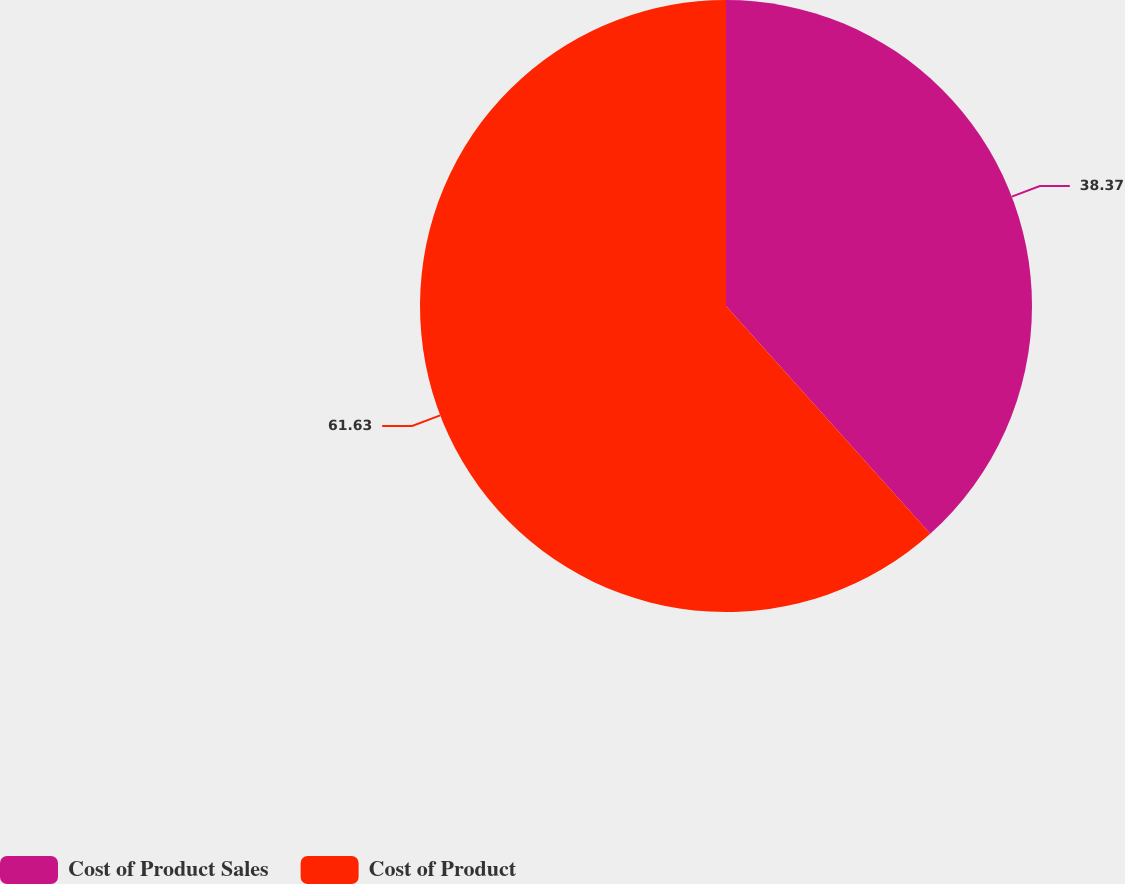Convert chart. <chart><loc_0><loc_0><loc_500><loc_500><pie_chart><fcel>Cost of Product Sales<fcel>Cost of Product<nl><fcel>38.37%<fcel>61.63%<nl></chart> 